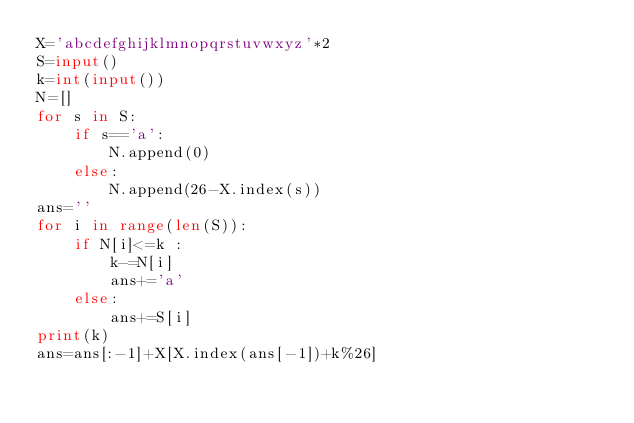<code> <loc_0><loc_0><loc_500><loc_500><_Python_>X='abcdefghijklmnopqrstuvwxyz'*2
S=input()
k=int(input())
N=[]
for s in S:
    if s=='a':
        N.append(0)
    else:
        N.append(26-X.index(s))
ans=''
for i in range(len(S)):
    if N[i]<=k :
        k-=N[i]
        ans+='a'
    else:
        ans+=S[i]
print(k)
ans=ans[:-1]+X[X.index(ans[-1])+k%26]</code> 